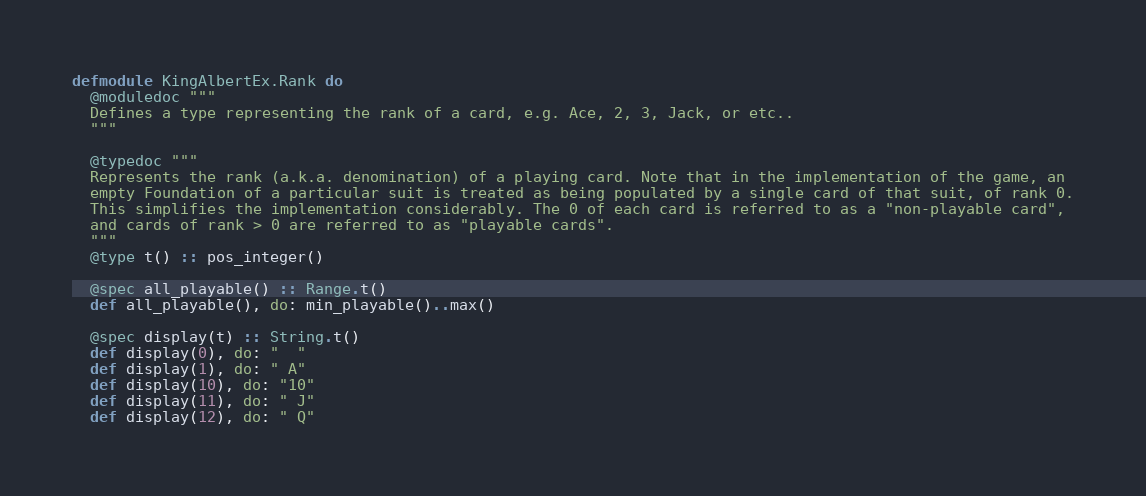<code> <loc_0><loc_0><loc_500><loc_500><_Elixir_>defmodule KingAlbertEx.Rank do
  @moduledoc """
  Defines a type representing the rank of a card, e.g. Ace, 2, 3, Jack, or etc..
  """

  @typedoc """
  Represents the rank (a.k.a. denomination) of a playing card. Note that in the implementation of the game, an
  empty Foundation of a particular suit is treated as being populated by a single card of that suit, of rank 0.
  This simplifies the implementation considerably. The 0 of each card is referred to as a "non-playable card",
  and cards of rank > 0 are referred to as "playable cards".
  """
  @type t() :: pos_integer()

  @spec all_playable() :: Range.t()
  def all_playable(), do: min_playable()..max()

  @spec display(t) :: String.t()
  def display(0), do: "  "
  def display(1), do: " A"
  def display(10), do: "10"
  def display(11), do: " J"
  def display(12), do: " Q"</code> 